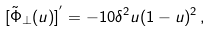<formula> <loc_0><loc_0><loc_500><loc_500>[ { \tilde { \Phi } } _ { \bot } ( u ) ] ^ { ^ { \prime } } = - 1 0 \delta ^ { 2 } u ( 1 - u ) ^ { 2 } \, ,</formula> 